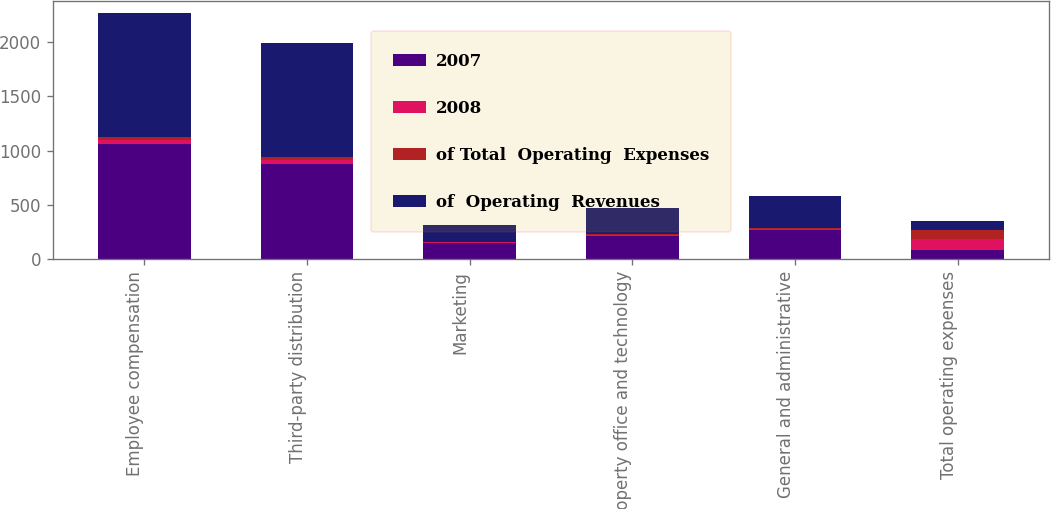<chart> <loc_0><loc_0><loc_500><loc_500><stacked_bar_chart><ecel><fcel>Employee compensation<fcel>Third-party distribution<fcel>Marketing<fcel>Property office and technology<fcel>General and administrative<fcel>Total operating expenses<nl><fcel>2007<fcel>1055.8<fcel>875.5<fcel>148.2<fcel>214.3<fcel>266<fcel>88.7<nl><fcel>2008<fcel>41.2<fcel>34.2<fcel>5.8<fcel>8.4<fcel>10.4<fcel>100<nl><fcel>of Total  Operating  Expenses<fcel>31.9<fcel>26.5<fcel>4.5<fcel>6.5<fcel>8<fcel>77.4<nl><fcel>of  Operating  Revenues<fcel>1137.6<fcel>1051.1<fcel>157.6<fcel>242.5<fcel>295.8<fcel>88.7<nl></chart> 